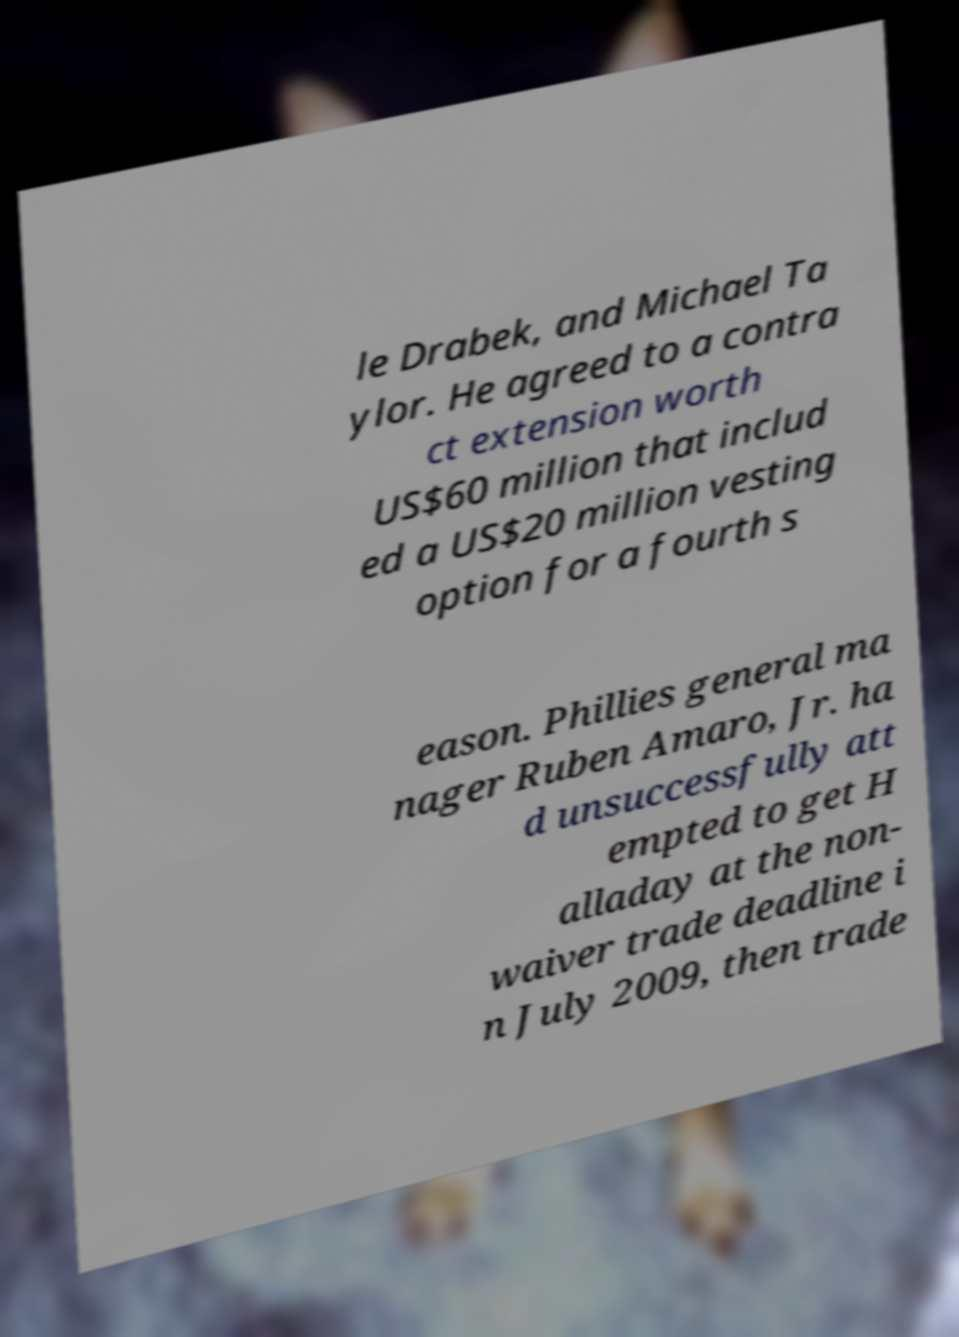There's text embedded in this image that I need extracted. Can you transcribe it verbatim? le Drabek, and Michael Ta ylor. He agreed to a contra ct extension worth US$60 million that includ ed a US$20 million vesting option for a fourth s eason. Phillies general ma nager Ruben Amaro, Jr. ha d unsuccessfully att empted to get H alladay at the non- waiver trade deadline i n July 2009, then trade 